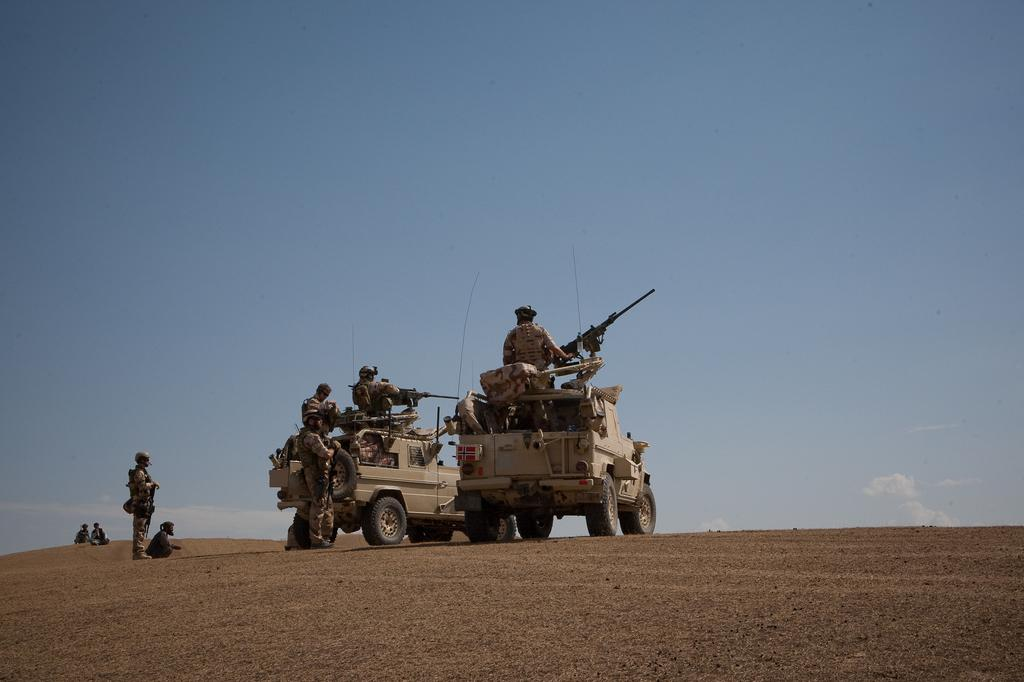How many people are in the image? There are people in the image, but the exact number is not specified. What are some of the people holding in the image? Some people are holding weapons in the image. How many vehicles can be seen in the image? There are two vehicles in the image. What is visible at the top of the image? The sky is visible at the top of the image. How does the pot help to prevent the earthquake in the image? There is no pot or earthquake present in the image, so this question cannot be answered. 